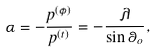<formula> <loc_0><loc_0><loc_500><loc_500>\alpha = - \frac { p ^ { ( \phi ) } } { p ^ { ( t ) } } = - \frac { \lambda } { \sin \theta _ { o } } ,</formula> 